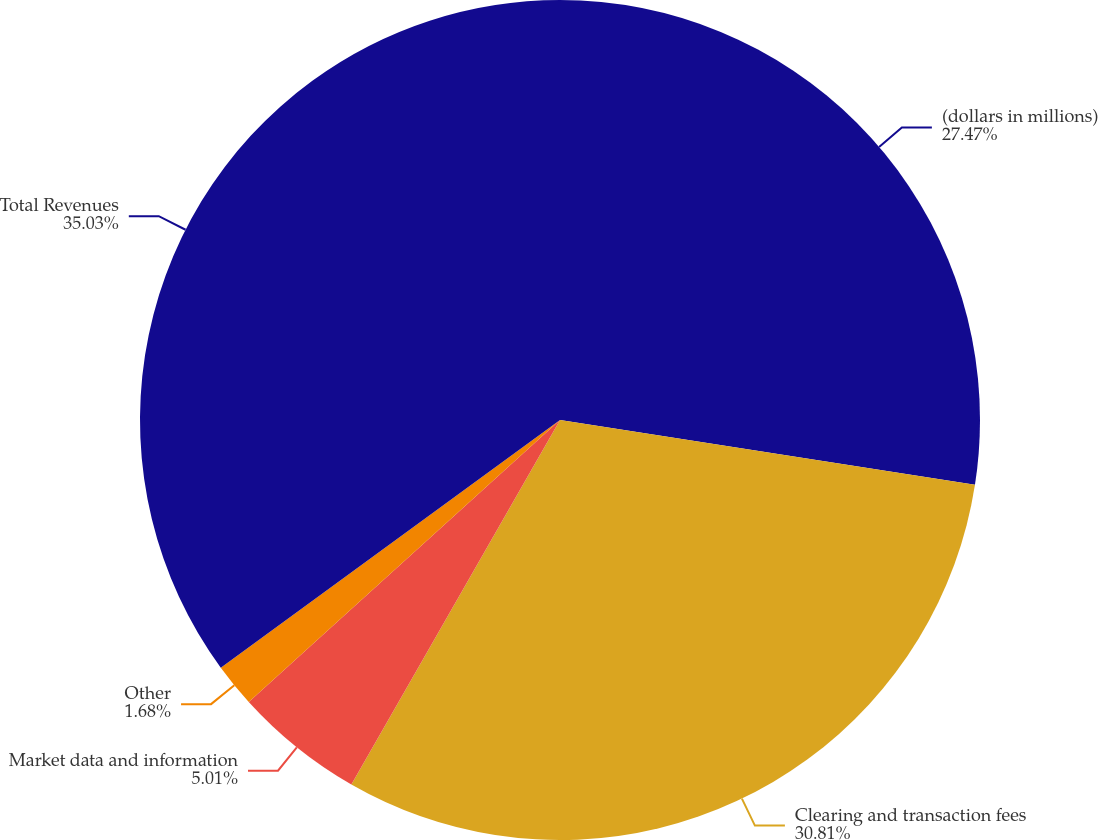<chart> <loc_0><loc_0><loc_500><loc_500><pie_chart><fcel>(dollars in millions)<fcel>Clearing and transaction fees<fcel>Market data and information<fcel>Other<fcel>Total Revenues<nl><fcel>27.47%<fcel>30.81%<fcel>5.01%<fcel>1.68%<fcel>35.04%<nl></chart> 